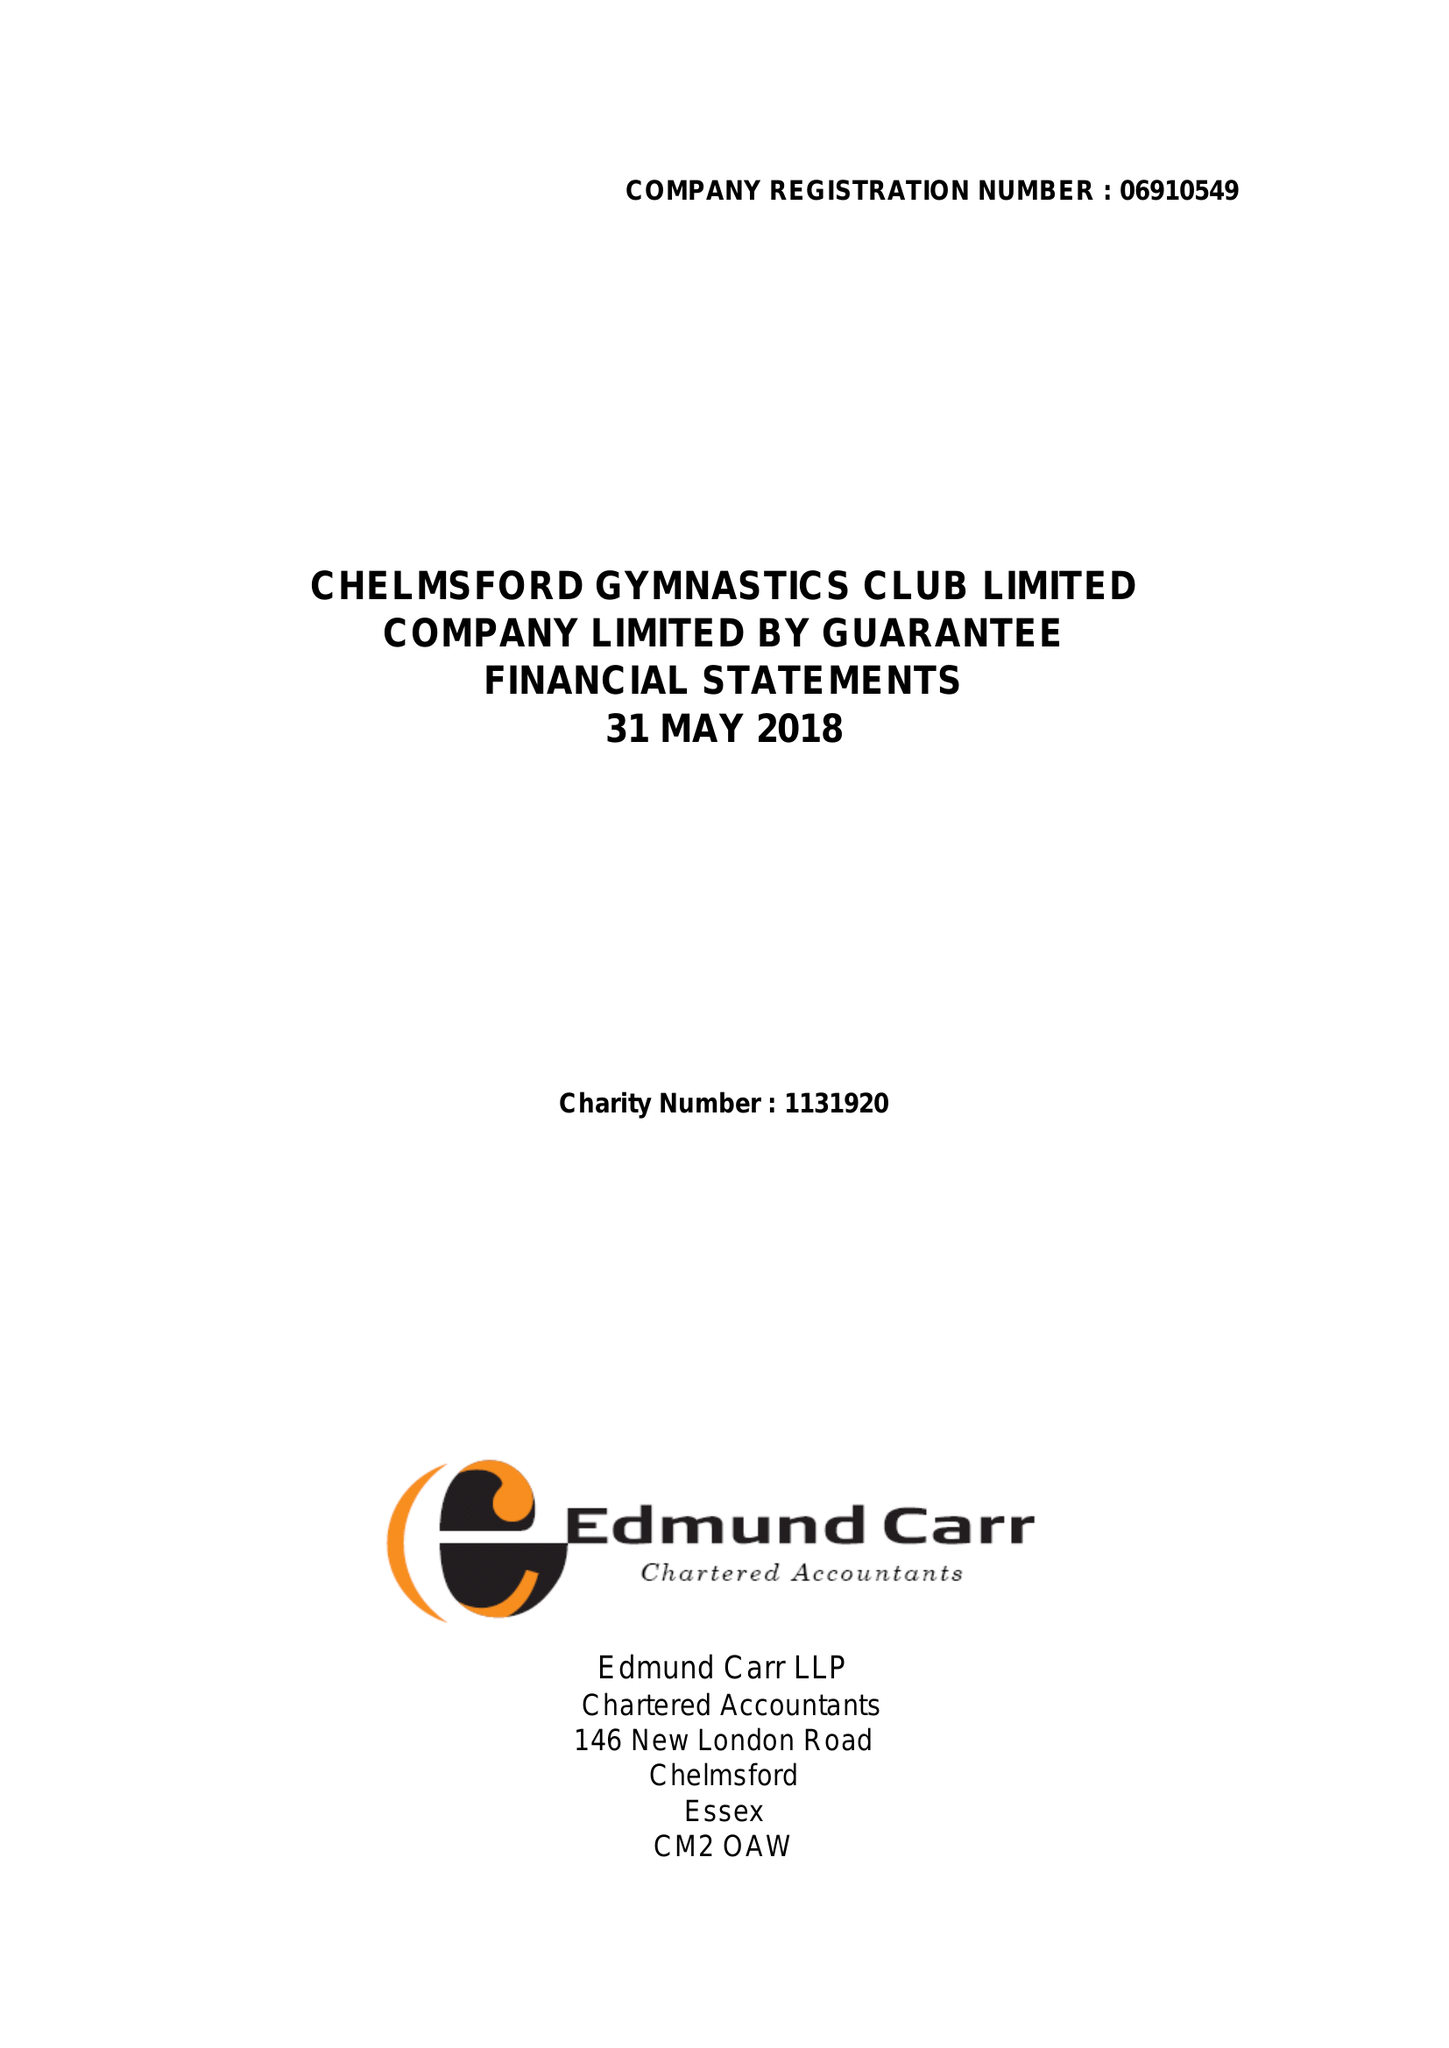What is the value for the charity_name?
Answer the question using a single word or phrase. Chelmsford Gymnastics Club Ltd. 